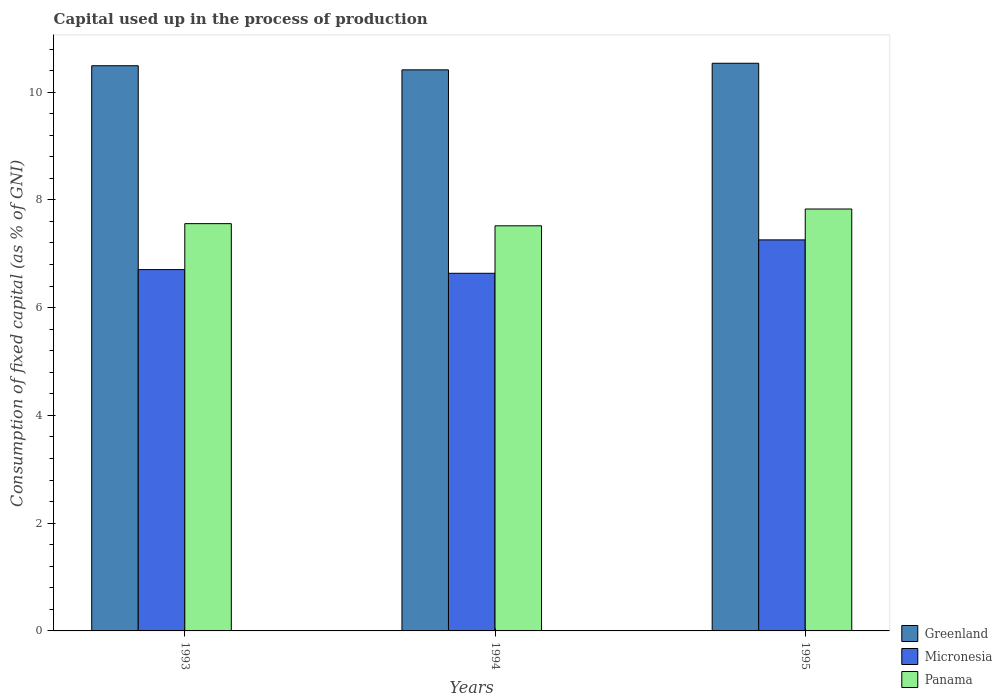How many groups of bars are there?
Your response must be concise. 3. Are the number of bars per tick equal to the number of legend labels?
Keep it short and to the point. Yes. How many bars are there on the 1st tick from the left?
Give a very brief answer. 3. What is the label of the 3rd group of bars from the left?
Offer a terse response. 1995. What is the capital used up in the process of production in Micronesia in 1993?
Offer a very short reply. 6.71. Across all years, what is the maximum capital used up in the process of production in Panama?
Provide a short and direct response. 7.83. Across all years, what is the minimum capital used up in the process of production in Panama?
Provide a short and direct response. 7.52. What is the total capital used up in the process of production in Greenland in the graph?
Your answer should be compact. 31.44. What is the difference between the capital used up in the process of production in Micronesia in 1993 and that in 1994?
Keep it short and to the point. 0.07. What is the difference between the capital used up in the process of production in Greenland in 1994 and the capital used up in the process of production in Panama in 1995?
Offer a very short reply. 2.58. What is the average capital used up in the process of production in Panama per year?
Offer a terse response. 7.64. In the year 1994, what is the difference between the capital used up in the process of production in Micronesia and capital used up in the process of production in Greenland?
Provide a succinct answer. -3.78. In how many years, is the capital used up in the process of production in Panama greater than 0.8 %?
Your answer should be compact. 3. What is the ratio of the capital used up in the process of production in Panama in 1993 to that in 1995?
Keep it short and to the point. 0.97. Is the difference between the capital used up in the process of production in Micronesia in 1993 and 1994 greater than the difference between the capital used up in the process of production in Greenland in 1993 and 1994?
Ensure brevity in your answer.  No. What is the difference between the highest and the second highest capital used up in the process of production in Panama?
Provide a short and direct response. 0.27. What is the difference between the highest and the lowest capital used up in the process of production in Panama?
Your response must be concise. 0.31. In how many years, is the capital used up in the process of production in Greenland greater than the average capital used up in the process of production in Greenland taken over all years?
Make the answer very short. 2. Is the sum of the capital used up in the process of production in Micronesia in 1993 and 1994 greater than the maximum capital used up in the process of production in Panama across all years?
Your answer should be compact. Yes. What does the 3rd bar from the left in 1993 represents?
Give a very brief answer. Panama. What does the 2nd bar from the right in 1994 represents?
Offer a terse response. Micronesia. Is it the case that in every year, the sum of the capital used up in the process of production in Greenland and capital used up in the process of production in Micronesia is greater than the capital used up in the process of production in Panama?
Your response must be concise. Yes. How many years are there in the graph?
Your answer should be compact. 3. What is the difference between two consecutive major ticks on the Y-axis?
Your answer should be compact. 2. Does the graph contain any zero values?
Make the answer very short. No. Does the graph contain grids?
Your answer should be compact. No. Where does the legend appear in the graph?
Your answer should be compact. Bottom right. How many legend labels are there?
Give a very brief answer. 3. What is the title of the graph?
Provide a succinct answer. Capital used up in the process of production. What is the label or title of the Y-axis?
Your answer should be compact. Consumption of fixed capital (as % of GNI). What is the Consumption of fixed capital (as % of GNI) in Greenland in 1993?
Offer a very short reply. 10.49. What is the Consumption of fixed capital (as % of GNI) of Micronesia in 1993?
Provide a short and direct response. 6.71. What is the Consumption of fixed capital (as % of GNI) in Panama in 1993?
Your response must be concise. 7.56. What is the Consumption of fixed capital (as % of GNI) of Greenland in 1994?
Your answer should be compact. 10.41. What is the Consumption of fixed capital (as % of GNI) of Micronesia in 1994?
Provide a succinct answer. 6.64. What is the Consumption of fixed capital (as % of GNI) in Panama in 1994?
Keep it short and to the point. 7.52. What is the Consumption of fixed capital (as % of GNI) of Greenland in 1995?
Provide a succinct answer. 10.54. What is the Consumption of fixed capital (as % of GNI) in Micronesia in 1995?
Ensure brevity in your answer.  7.26. What is the Consumption of fixed capital (as % of GNI) in Panama in 1995?
Keep it short and to the point. 7.83. Across all years, what is the maximum Consumption of fixed capital (as % of GNI) in Greenland?
Provide a succinct answer. 10.54. Across all years, what is the maximum Consumption of fixed capital (as % of GNI) of Micronesia?
Ensure brevity in your answer.  7.26. Across all years, what is the maximum Consumption of fixed capital (as % of GNI) of Panama?
Your response must be concise. 7.83. Across all years, what is the minimum Consumption of fixed capital (as % of GNI) of Greenland?
Your answer should be compact. 10.41. Across all years, what is the minimum Consumption of fixed capital (as % of GNI) in Micronesia?
Make the answer very short. 6.64. Across all years, what is the minimum Consumption of fixed capital (as % of GNI) of Panama?
Your answer should be compact. 7.52. What is the total Consumption of fixed capital (as % of GNI) of Greenland in the graph?
Ensure brevity in your answer.  31.44. What is the total Consumption of fixed capital (as % of GNI) of Micronesia in the graph?
Keep it short and to the point. 20.6. What is the total Consumption of fixed capital (as % of GNI) in Panama in the graph?
Ensure brevity in your answer.  22.91. What is the difference between the Consumption of fixed capital (as % of GNI) of Greenland in 1993 and that in 1994?
Your answer should be very brief. 0.08. What is the difference between the Consumption of fixed capital (as % of GNI) of Micronesia in 1993 and that in 1994?
Offer a very short reply. 0.07. What is the difference between the Consumption of fixed capital (as % of GNI) in Greenland in 1993 and that in 1995?
Keep it short and to the point. -0.05. What is the difference between the Consumption of fixed capital (as % of GNI) of Micronesia in 1993 and that in 1995?
Make the answer very short. -0.55. What is the difference between the Consumption of fixed capital (as % of GNI) in Panama in 1993 and that in 1995?
Offer a terse response. -0.27. What is the difference between the Consumption of fixed capital (as % of GNI) of Greenland in 1994 and that in 1995?
Keep it short and to the point. -0.12. What is the difference between the Consumption of fixed capital (as % of GNI) of Micronesia in 1994 and that in 1995?
Keep it short and to the point. -0.62. What is the difference between the Consumption of fixed capital (as % of GNI) in Panama in 1994 and that in 1995?
Provide a succinct answer. -0.31. What is the difference between the Consumption of fixed capital (as % of GNI) in Greenland in 1993 and the Consumption of fixed capital (as % of GNI) in Micronesia in 1994?
Provide a succinct answer. 3.85. What is the difference between the Consumption of fixed capital (as % of GNI) of Greenland in 1993 and the Consumption of fixed capital (as % of GNI) of Panama in 1994?
Offer a terse response. 2.97. What is the difference between the Consumption of fixed capital (as % of GNI) of Micronesia in 1993 and the Consumption of fixed capital (as % of GNI) of Panama in 1994?
Ensure brevity in your answer.  -0.81. What is the difference between the Consumption of fixed capital (as % of GNI) in Greenland in 1993 and the Consumption of fixed capital (as % of GNI) in Micronesia in 1995?
Keep it short and to the point. 3.23. What is the difference between the Consumption of fixed capital (as % of GNI) in Greenland in 1993 and the Consumption of fixed capital (as % of GNI) in Panama in 1995?
Give a very brief answer. 2.66. What is the difference between the Consumption of fixed capital (as % of GNI) of Micronesia in 1993 and the Consumption of fixed capital (as % of GNI) of Panama in 1995?
Provide a short and direct response. -1.12. What is the difference between the Consumption of fixed capital (as % of GNI) of Greenland in 1994 and the Consumption of fixed capital (as % of GNI) of Micronesia in 1995?
Ensure brevity in your answer.  3.16. What is the difference between the Consumption of fixed capital (as % of GNI) of Greenland in 1994 and the Consumption of fixed capital (as % of GNI) of Panama in 1995?
Offer a very short reply. 2.58. What is the difference between the Consumption of fixed capital (as % of GNI) in Micronesia in 1994 and the Consumption of fixed capital (as % of GNI) in Panama in 1995?
Keep it short and to the point. -1.19. What is the average Consumption of fixed capital (as % of GNI) in Greenland per year?
Your response must be concise. 10.48. What is the average Consumption of fixed capital (as % of GNI) in Micronesia per year?
Ensure brevity in your answer.  6.87. What is the average Consumption of fixed capital (as % of GNI) in Panama per year?
Provide a succinct answer. 7.64. In the year 1993, what is the difference between the Consumption of fixed capital (as % of GNI) in Greenland and Consumption of fixed capital (as % of GNI) in Micronesia?
Your response must be concise. 3.78. In the year 1993, what is the difference between the Consumption of fixed capital (as % of GNI) of Greenland and Consumption of fixed capital (as % of GNI) of Panama?
Your answer should be compact. 2.93. In the year 1993, what is the difference between the Consumption of fixed capital (as % of GNI) of Micronesia and Consumption of fixed capital (as % of GNI) of Panama?
Make the answer very short. -0.85. In the year 1994, what is the difference between the Consumption of fixed capital (as % of GNI) of Greenland and Consumption of fixed capital (as % of GNI) of Micronesia?
Offer a terse response. 3.78. In the year 1994, what is the difference between the Consumption of fixed capital (as % of GNI) in Greenland and Consumption of fixed capital (as % of GNI) in Panama?
Your response must be concise. 2.89. In the year 1994, what is the difference between the Consumption of fixed capital (as % of GNI) of Micronesia and Consumption of fixed capital (as % of GNI) of Panama?
Offer a very short reply. -0.88. In the year 1995, what is the difference between the Consumption of fixed capital (as % of GNI) of Greenland and Consumption of fixed capital (as % of GNI) of Micronesia?
Provide a succinct answer. 3.28. In the year 1995, what is the difference between the Consumption of fixed capital (as % of GNI) in Greenland and Consumption of fixed capital (as % of GNI) in Panama?
Offer a very short reply. 2.71. In the year 1995, what is the difference between the Consumption of fixed capital (as % of GNI) of Micronesia and Consumption of fixed capital (as % of GNI) of Panama?
Provide a short and direct response. -0.57. What is the ratio of the Consumption of fixed capital (as % of GNI) of Greenland in 1993 to that in 1994?
Your answer should be very brief. 1.01. What is the ratio of the Consumption of fixed capital (as % of GNI) in Micronesia in 1993 to that in 1994?
Provide a succinct answer. 1.01. What is the ratio of the Consumption of fixed capital (as % of GNI) in Panama in 1993 to that in 1994?
Provide a succinct answer. 1.01. What is the ratio of the Consumption of fixed capital (as % of GNI) of Micronesia in 1993 to that in 1995?
Your answer should be very brief. 0.92. What is the ratio of the Consumption of fixed capital (as % of GNI) in Panama in 1993 to that in 1995?
Make the answer very short. 0.97. What is the ratio of the Consumption of fixed capital (as % of GNI) in Greenland in 1994 to that in 1995?
Make the answer very short. 0.99. What is the ratio of the Consumption of fixed capital (as % of GNI) of Micronesia in 1994 to that in 1995?
Offer a terse response. 0.91. What is the ratio of the Consumption of fixed capital (as % of GNI) of Panama in 1994 to that in 1995?
Provide a short and direct response. 0.96. What is the difference between the highest and the second highest Consumption of fixed capital (as % of GNI) of Greenland?
Provide a succinct answer. 0.05. What is the difference between the highest and the second highest Consumption of fixed capital (as % of GNI) in Micronesia?
Provide a short and direct response. 0.55. What is the difference between the highest and the second highest Consumption of fixed capital (as % of GNI) in Panama?
Make the answer very short. 0.27. What is the difference between the highest and the lowest Consumption of fixed capital (as % of GNI) in Greenland?
Your answer should be compact. 0.12. What is the difference between the highest and the lowest Consumption of fixed capital (as % of GNI) of Micronesia?
Provide a succinct answer. 0.62. What is the difference between the highest and the lowest Consumption of fixed capital (as % of GNI) of Panama?
Ensure brevity in your answer.  0.31. 